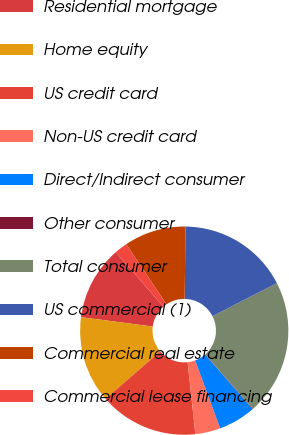Convert chart to OTSL. <chart><loc_0><loc_0><loc_500><loc_500><pie_chart><fcel>Residential mortgage<fcel>Home equity<fcel>US credit card<fcel>Non-US credit card<fcel>Direct/Indirect consumer<fcel>Other consumer<fcel>Total consumer<fcel>US commercial (1)<fcel>Commercial real estate<fcel>Commercial lease financing<nl><fcel>11.53%<fcel>13.43%<fcel>15.34%<fcel>3.9%<fcel>5.8%<fcel>0.08%<fcel>21.06%<fcel>17.25%<fcel>9.62%<fcel>1.99%<nl></chart> 